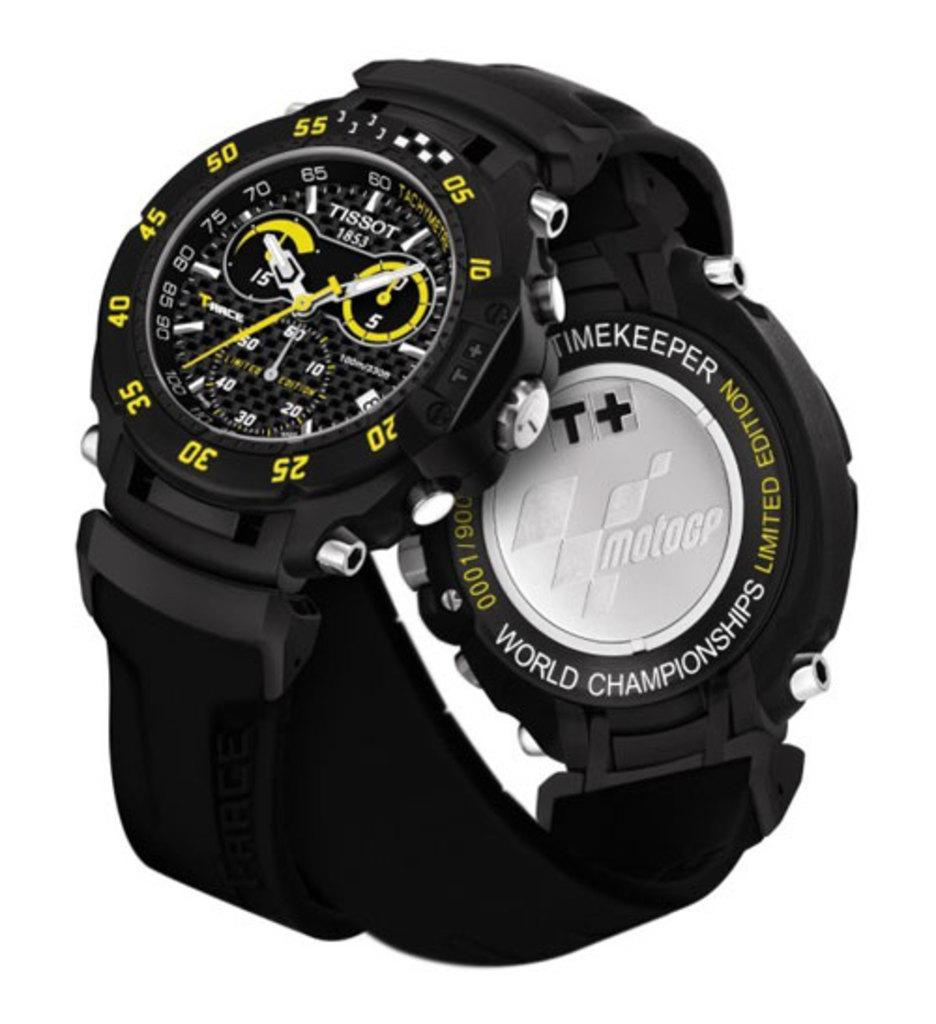<image>
Present a compact description of the photo's key features. The limited edition world championship watch has a fancy design. 